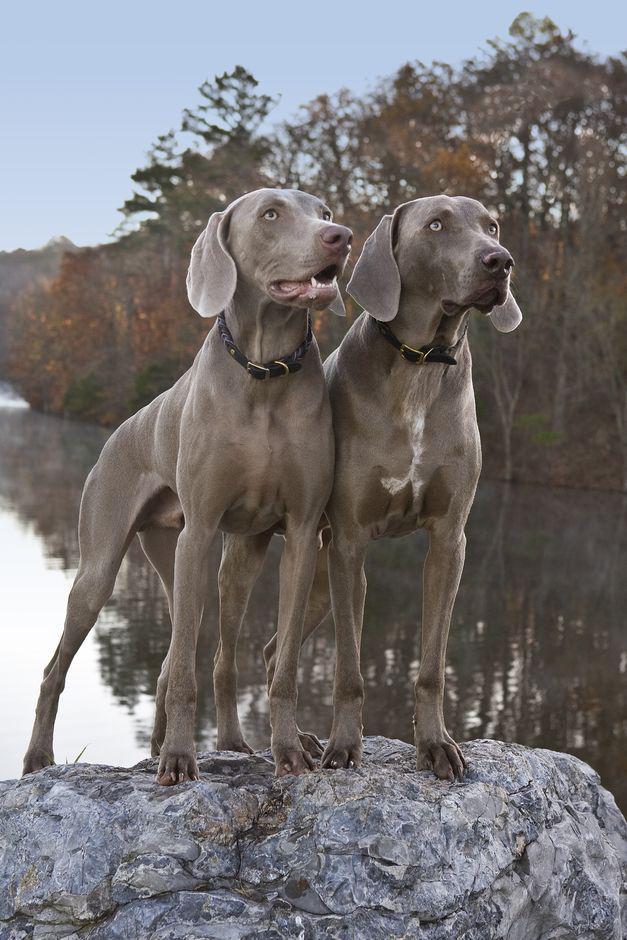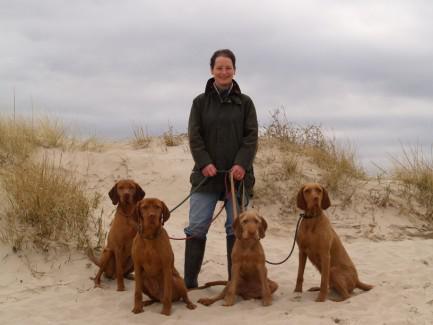The first image is the image on the left, the second image is the image on the right. Assess this claim about the two images: "In one image, exactly four dogs are at an outdoor location with one or more people.". Correct or not? Answer yes or no. Yes. The first image is the image on the left, the second image is the image on the right. For the images displayed, is the sentence "At least some of the dogs are on a leash." factually correct? Answer yes or no. Yes. 